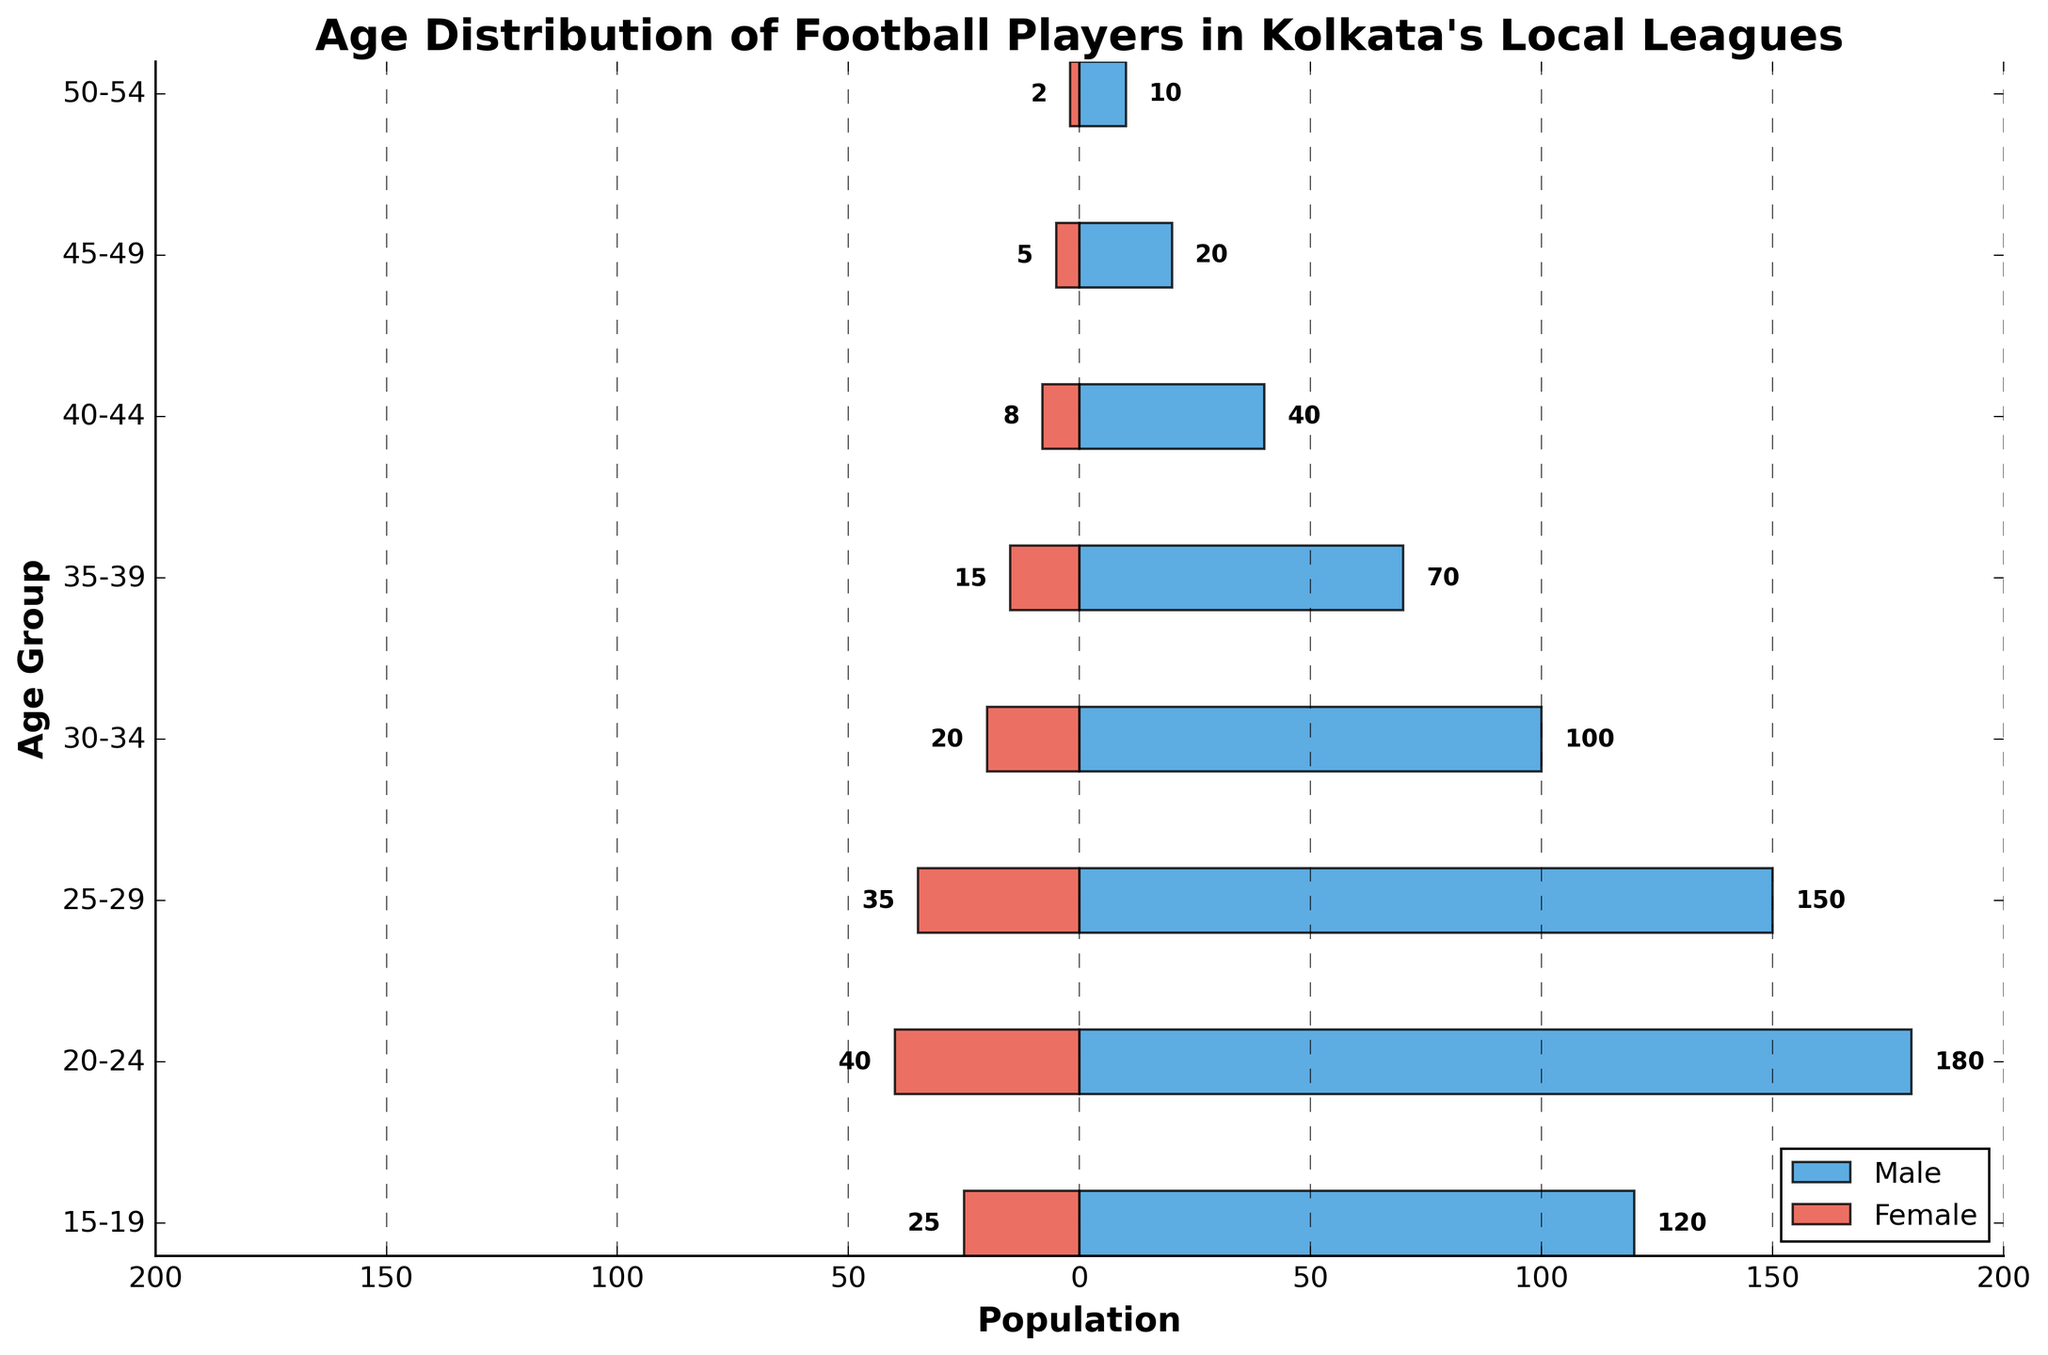What is the title of the plot? At the top of the plot, there is a bold and large text indicating what the plot is about. It reads "Age Distribution of Football Players in Kolkata's Local Leagues."
Answer: Age Distribution of Football Players in Kolkata's Local Leagues Which age group has the highest number of male football players? By examining the length of the blue bars representing males, the age group 20-24 has the longest bar, indicating the highest number of male football players.
Answer: 20-24 What is the age group with the least number of female players? By observing the lengths of the red bars representing females, the age group 50-54 has the shortest bar, indicating the least number of female players.
Answer: 50-54 What is the combined total number of football players (both male and female) in the age group 15-19? For age group 15-19, the blue bar (male) length is 120 and the red bar (female) length is 25. Adding these gives 120 + 25 = 145.
Answer: 145 How does the number of female players in the 25-29 age group compare to the number of male players in the same group? Looking at the bars for the 25-29 age group, the red bar (female) length is 35 and the blue bar (male) length is 150. We can see that there are significantly fewer female players than male players in this age group.
Answer: Fewer females than males In which age group is the male to female player ratio closest to 2:1? To determine this, we calculate the ratios: 
15-19 (120/25 = 4.8), 
20-24 (180/40 = 4.5), 
25-29 (150/35 ≈ 4.3), 
30-34 (100/20 = 5), 
35-39 (70/15 ≈ 4.7), 
40-44 (40/8 = 5), 
45-49 (20/5 = 4), 
50-54 (10/2 = 5). 
None of the ratios are exactly 2:1 but the closest is 45-49 with a ratio of 20/5 = 4.
Answer: None What is the average number of male players across all age groups? Summing the male players and then dividing by the number of age groups, we have: 
(120 + 180 + 150 + 100 + 70 + 40 + 20 + 10) / 8 = 690 / 8 = 86.25.
Answer: 86.25 